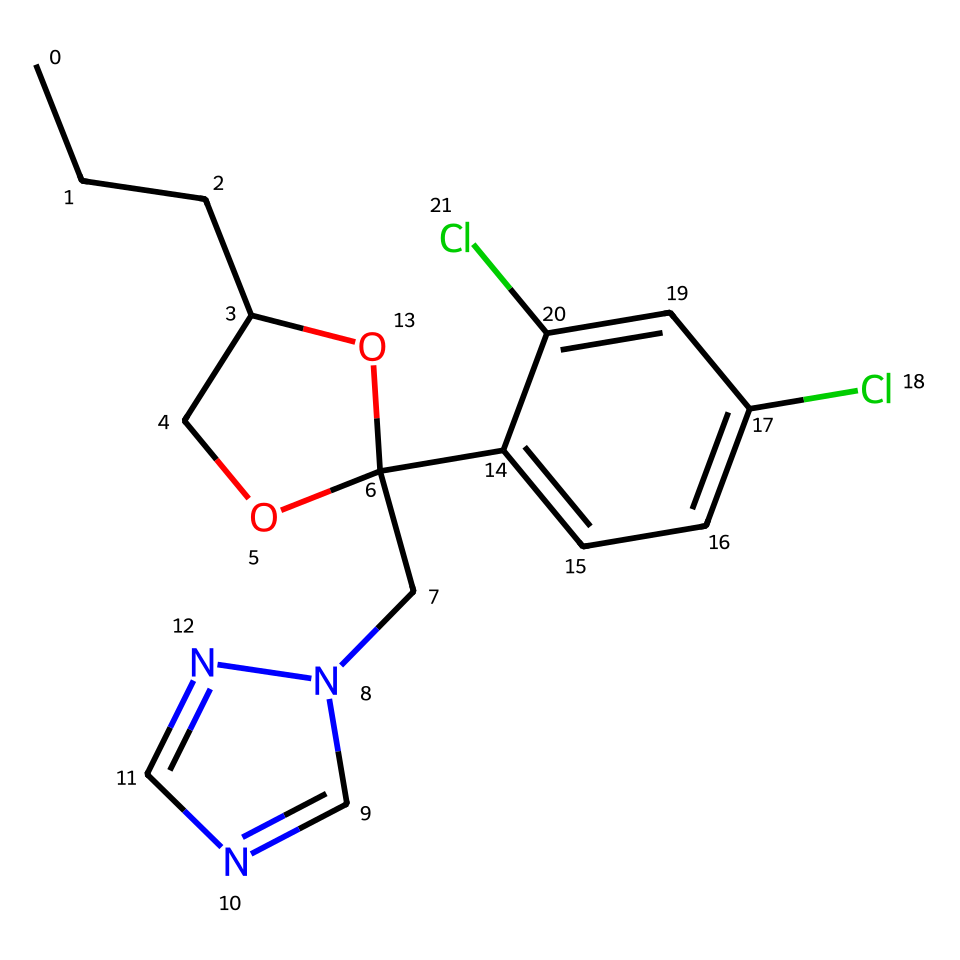What is the molecular formula of propiconazole? To determine the molecular formula from the SMILES string, we count the number of each type of atom indicated. The structure represents 15 carbon (C) atoms, 18 hydrogen (H) atoms, 2 chlorine (Cl) atoms, 1 oxygen (O) atom, and 4 nitrogen (N) atoms. Therefore, the molecular formula is C15H18Cl2N4O.
Answer: C15H18Cl2N4O How many rings are present in the structure? By analyzing the structure derived from the SMILES, we can identify the cyclic portions. In this case, there is one five-membered ring (the oxirane) and one six-membered ring (the benzene). Thus, there are two rings total in the structure.
Answer: 2 What functional groups are present in propiconazole? Looking at the SMILES, we can identify functional groups such as alcohol (–OH) due to the presence of the oxygen attached to a carbon (the –OH group), and an ether group due to the carbon–oxygen–carbon framework. Additionally, the structure contains a tertiary amine from the carbon bonded to a nitrogen.
Answer: alcohol, ether, amine How many chlorine atoms are attached to the structure? The structure indicates two chlorine atoms, as noted in the SMILES where "Cl" appears twice. This clearly shows the presence of two chlorine substituents on the benzene ring.
Answer: 2 Is propiconazole a single molecular entity or a polymer? The SMILES represents a single, discrete molecular compound without repeating units characteristic of polymers. The lack of any notation suggesting multiple linking units confirms that it is a singular molecular entity.
Answer: single molecular entity What type of activity is propiconazole primarily associated with? Propiconazole is primarily recognized for its fungicidal activity, as it's designed to inhibit the growth of fungi and is widely used in agricultural and building applications. The presence of nitrogen heterocycles is common in fungicides.
Answer: fungicidal activity 